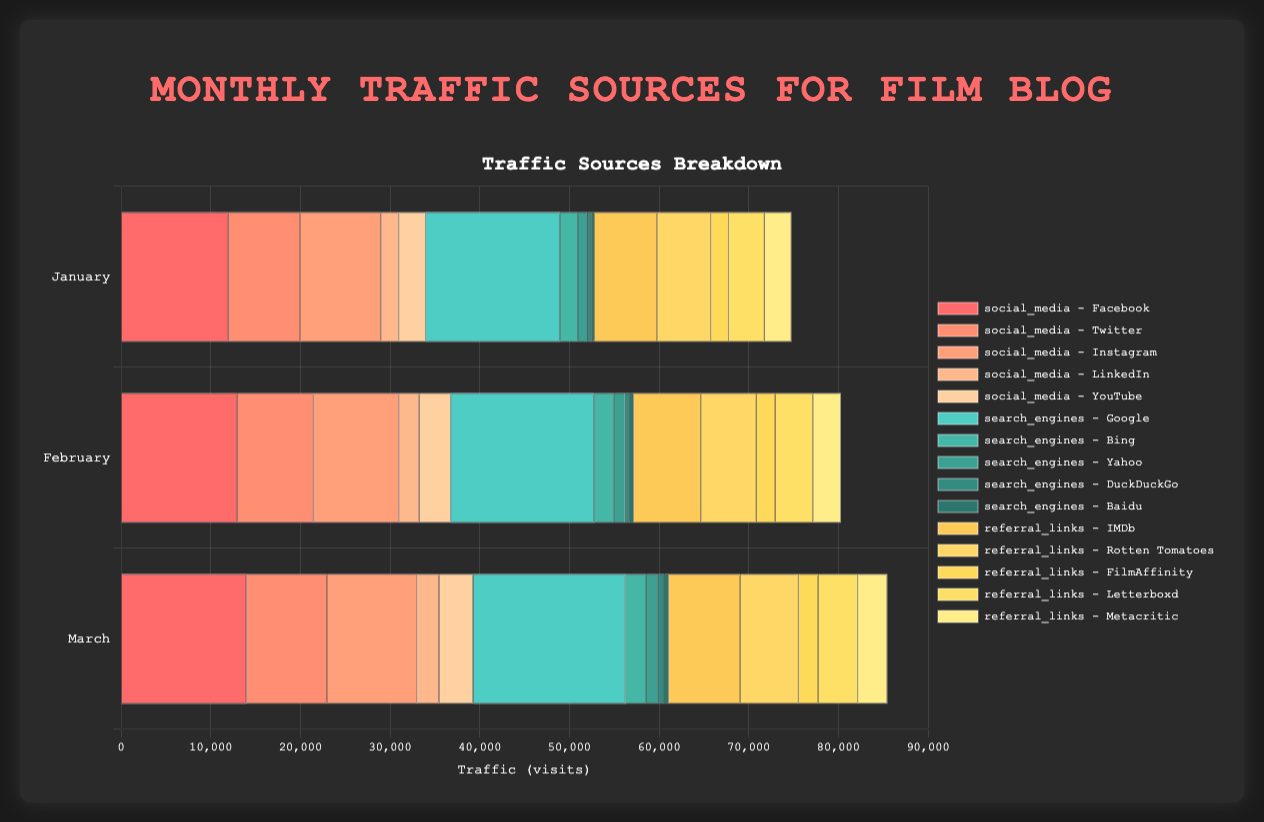Which month had the highest traffic from search engines? The highest traffic from search engines can be determined by adding up the individual search engine visits for each month and comparing the totals. For January: 15000 (Google) + 2000 (Bing) + 1000 (Yahoo) + 500 (DuckDuckGo) + 300 (Baidu) = 18800. For February: 16000 (Google) + 2200 (Bing) + 1200 (Yahoo) + 600 (DuckDuckGo) + 400 (Baidu) = 20400. For March: 17000 (Google) + 2300 (Bing) + 1300 (Yahoo) + 700 (DuckDuckGo) + 500 (Baidu) = 21800. Therefore, March had the highest traffic from search engines.
Answer: March What's the total traffic of referral links in February? Sum the referral link visits in February: 7500 (IMDb) + 6200 (Rotten Tomatoes) + 2100 (FilmAffinity) + 4200 (Letterboxd) + 3100 (Metacritic) = 23100.
Answer: 23100 Compare Facebook and Instagram traffic in January. Which one had more visits and by how much? Facebook had 12000 visits in January, and Instagram had 9000 visits. The difference is 12000 - 9000 = 3000. So, Facebook had more visits by 3000.
Answer: Facebook had more visits by 3000 What is the total traffic for March across all sources? Sum all the visits for March: Social Media: 14000 (Facebook) + 9000 (Twitter) + 10000 (Instagram) + 2500 (LinkedIn) + 3800 (YouTube) = 39300. Search Engines: 17000 (Google) + 2300 (Bing) + 1300 (Yahoo) + 700 (DuckDuckGo) + 500 (Baidu) = 21800. Referral Links: 8000 (IMDb) + 6500 (Rotten Tomatoes) + 2200 (FilmAffinity) + 4400 (Letterboxd) + 3300 (Metacritic) = 24400. Total traffic for March = 39300 + 21800 + 24400 = 85500.
Answer: 85500 Which referral link consistently brought the least traffic over the three months? For each month, check the referral links: January: FilmAffinity (2000). February: FilmAffinity (2100). March: FilmAffinity (2200). Therefore, FilmAffinity consistently brought the least traffic.
Answer: FilmAffinity What is the growth in traffic from LinkedIn from January to March? LinkedIn traffic in January was 2000, and in March it was 2500. The growth is 2500 - 2000 = 500.
Answer: 500 What is the average traffic from YouTube over the three months? Sum the YouTube visits over the three months and divide by 3: January (3000) + February (3500) + March (3800) = 10300. Average = 10300 / 3 ≈ 3433.33.
Answer: 3433.33 Compare the combined traffic of Twitter and LinkedIn in February to March. Which month had more combined traffic? For February: Twitter (8500) + LinkedIn (2300) = 10800. For March: Twitter (9000) + LinkedIn (2500) = 11500. March had more combined traffic.
Answer: March Which month showed the highest traffic from IMDb? IMDb traffic for each month is: January (7000), February (7500), March (8000). Therefore, March had the highest IMDb traffic.
Answer: March 